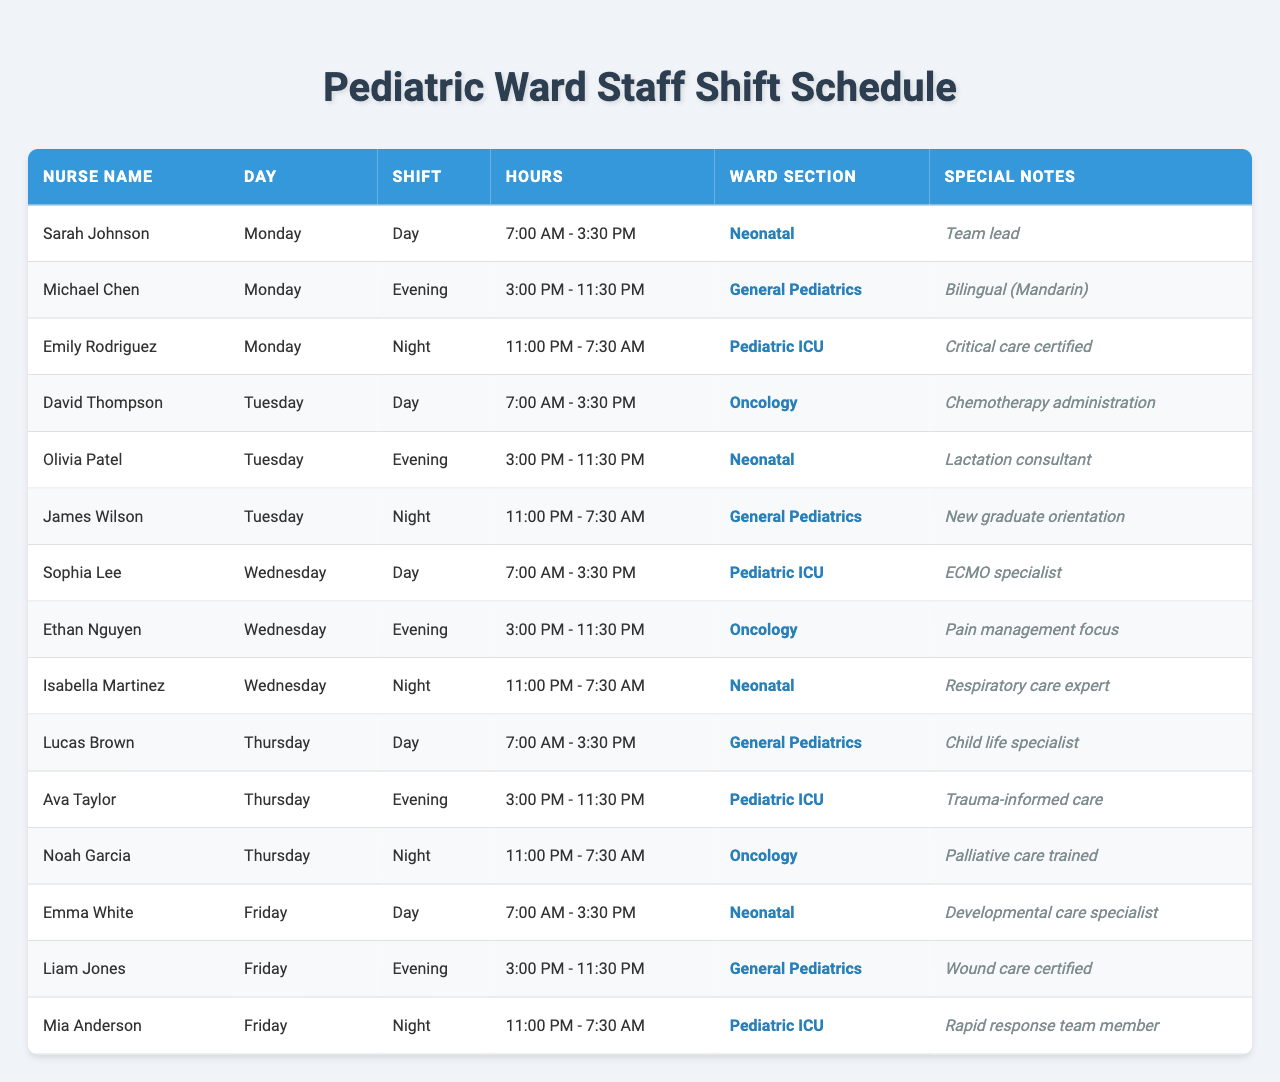What are the names of the nurses working the day shift on Tuesday? The day shifts on Tuesday are covered by David Thompson, who works from 7:00 AM to 3:30 PM, and since it's the only day listed for that shift, there are no other nurses assigned to that shift.
Answer: David Thompson Which section has the most nurses scheduled for the night shift? We look at the night shifts: Pediatric ICU has Mia Anderson and Emily Rodriguez, Oncology has Noah Garcia, and General Pediatrics has James Wilson. Since Pediatric ICU has two nurses scheduled, it has the most.
Answer: Pediatric ICU Is there any nurse assigned to the Neonatal section on Friday? Looking at the schedule for Friday, we can find Emma White assigned to Neonatal for the day shift.
Answer: Yes How many nurses are working on Monday? The schedule lists three nurses for Monday: Sarah Johnson, Michael Chen, and Emily Rodriguez, covering different shifts.
Answer: Three Which nurses are specialized in Trauma-informed care and Lactation consulting? Checking the special notes for Thursday, we see that Ava Taylor is specialized in Trauma-informed care, and Olivia Patel is a Lactation consultant listed for Tuesday.
Answer: Ava Taylor and Olivia Patel Does any nurse on the schedule speak Mandarin? The special notes indicate that Michael Chen is bilingual in Mandarin, making him the only nurse listed with that capability.
Answer: Yes How many nurses work in the Pediatric ICU during the week? Checking the shifts, Sophia Lee and Mia Anderson work in Pediatric ICU on Wednesday and Friday, respectively. Thus, there are two distinct nurses assigned there.
Answer: Two What are the shift hours for the general pediatrics night shift on Tuesday? Looking at the schedule, James Wilson is assigned to the night shift on Tuesday, which runs from 11:00 PM to 7:30 AM.
Answer: 11:00 PM - 7:30 AM Which day has the least number of nurses scheduled? Upon examining the schedule, each day has three nurses working, so all days are equal in terms of the number of nurses scheduled, with no day having fewer than that.
Answer: None Which nurse has critical care certification? According to the special notes, Emily Rodriguez has critical care certification and is scheduled for the night shift on Monday in the Pediatric ICU.
Answer: Emily Rodriguez 